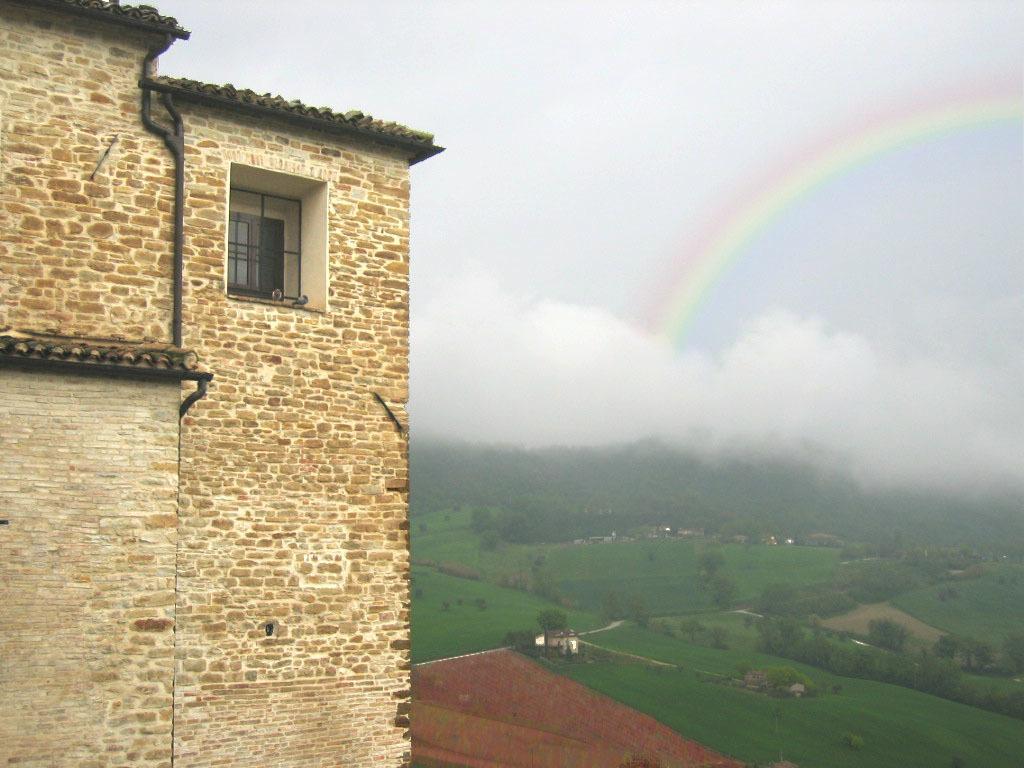Describe this image in one or two sentences. In this picture on the right side, we can see the ground covered with red mud and grass fields surrounded by trees and fog. On the left side, we can see a building made of bricks and windows. The sky is cloudy with a rainbow. 